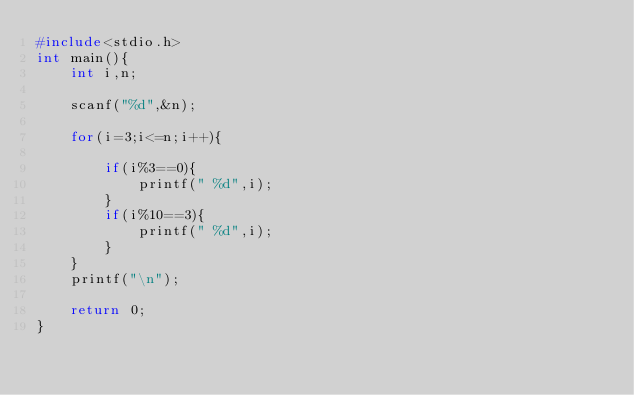Convert code to text. <code><loc_0><loc_0><loc_500><loc_500><_C_>#include<stdio.h>
int main(){
	int i,n;
	
	scanf("%d",&n);
	
	for(i=3;i<=n;i++){
		
		if(i%3==0){
			printf(" %d",i);
		}
		if(i%10==3){
			printf(" %d",i);
		}
	}
	printf("\n");
	
	return 0;
}
</code> 